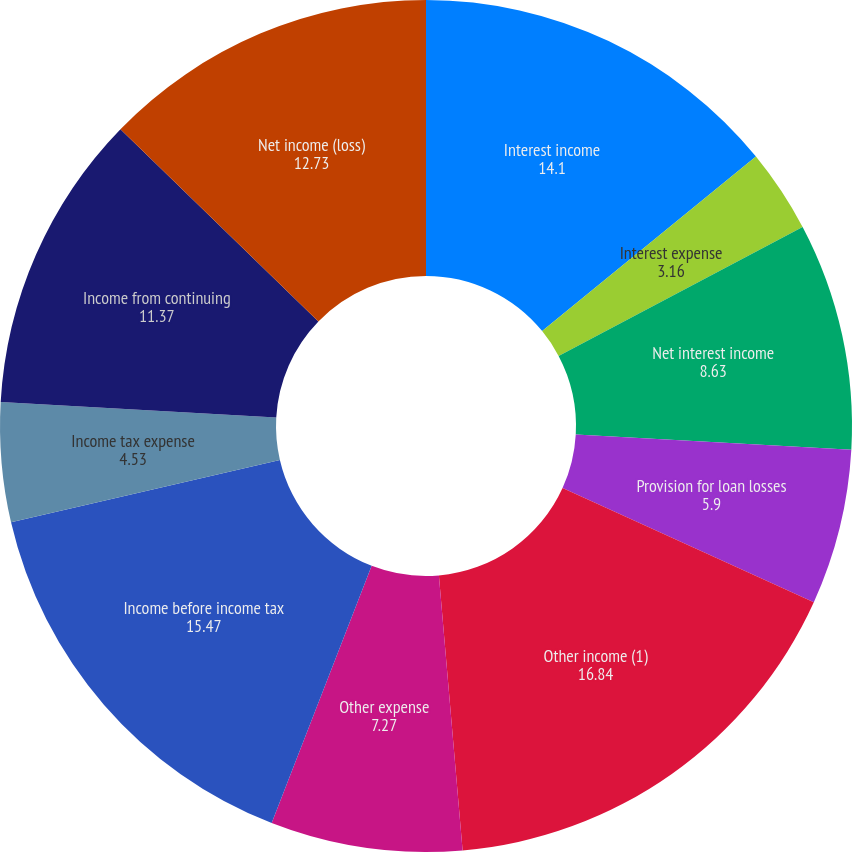Convert chart. <chart><loc_0><loc_0><loc_500><loc_500><pie_chart><fcel>Interest income<fcel>Interest expense<fcel>Net interest income<fcel>Provision for loan losses<fcel>Other income (1)<fcel>Other expense<fcel>Income before income tax<fcel>Income tax expense<fcel>Income from continuing<fcel>Net income (loss)<nl><fcel>14.1%<fcel>3.16%<fcel>8.63%<fcel>5.9%<fcel>16.84%<fcel>7.27%<fcel>15.47%<fcel>4.53%<fcel>11.37%<fcel>12.73%<nl></chart> 